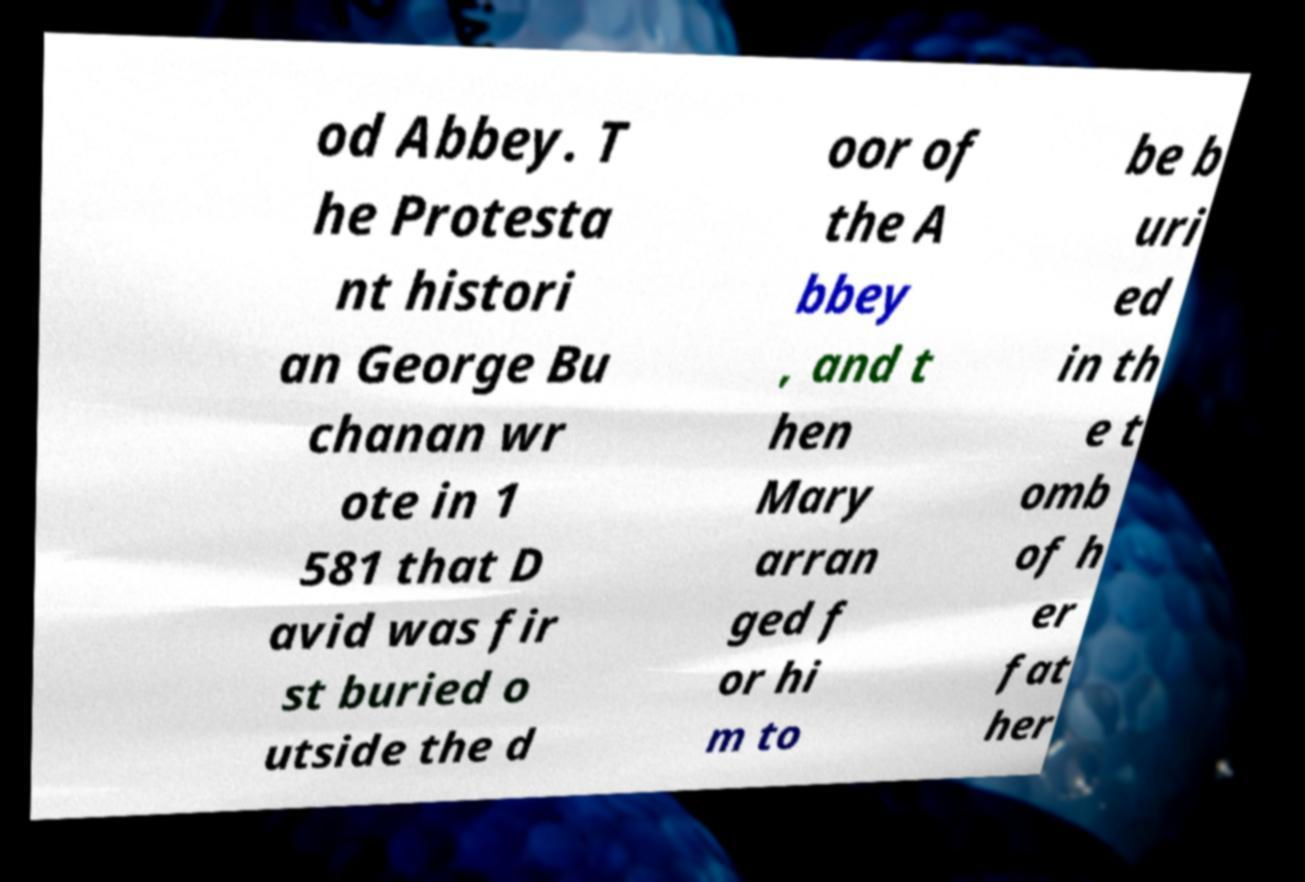There's text embedded in this image that I need extracted. Can you transcribe it verbatim? od Abbey. T he Protesta nt histori an George Bu chanan wr ote in 1 581 that D avid was fir st buried o utside the d oor of the A bbey , and t hen Mary arran ged f or hi m to be b uri ed in th e t omb of h er fat her 